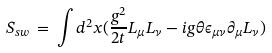Convert formula to latex. <formula><loc_0><loc_0><loc_500><loc_500>S _ { s w } \, = \, \int d ^ { 2 } x ( \frac { g ^ { 2 } } { 2 t } L _ { \mu } L _ { \nu } - i g \theta \epsilon _ { \mu \nu } \partial _ { \mu } L _ { \nu } )</formula> 